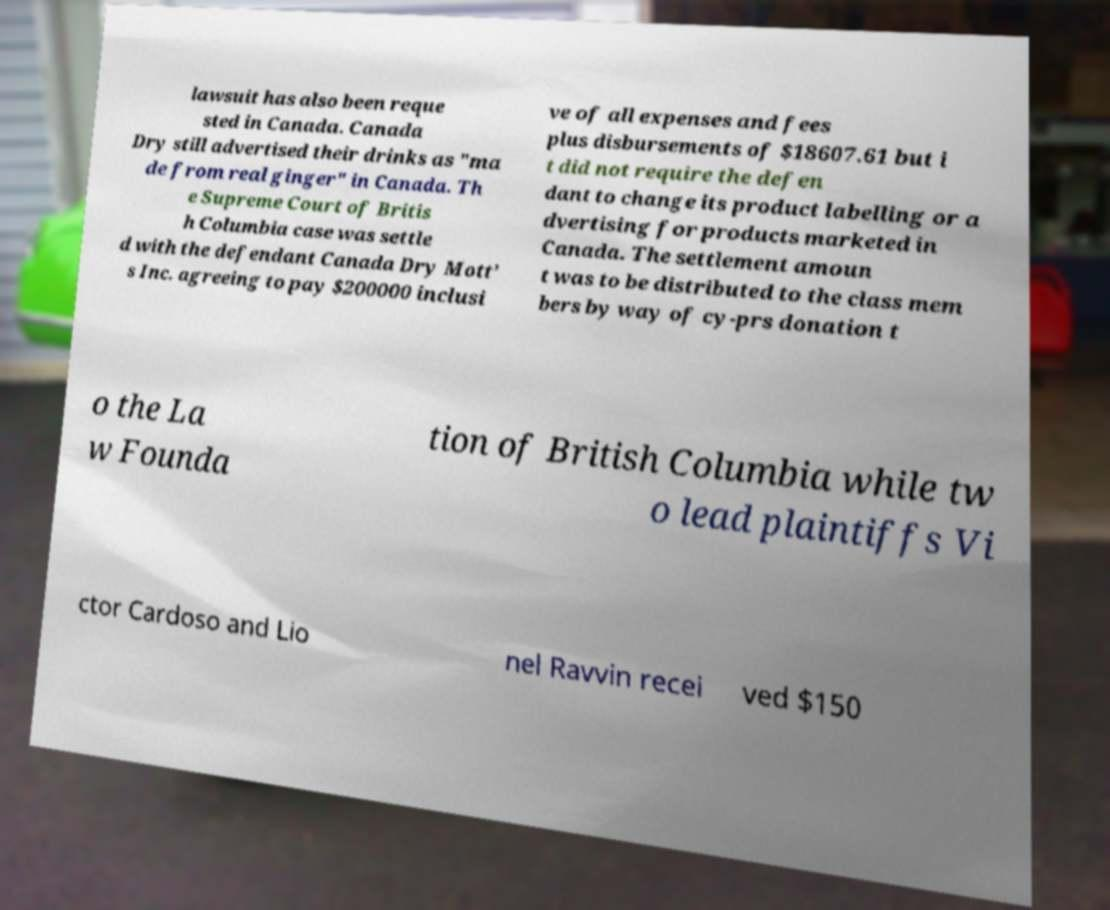Can you accurately transcribe the text from the provided image for me? lawsuit has also been reque sted in Canada. Canada Dry still advertised their drinks as "ma de from real ginger" in Canada. Th e Supreme Court of Britis h Columbia case was settle d with the defendant Canada Dry Mott’ s Inc. agreeing to pay $200000 inclusi ve of all expenses and fees plus disbursements of $18607.61 but i t did not require the defen dant to change its product labelling or a dvertising for products marketed in Canada. The settlement amoun t was to be distributed to the class mem bers by way of cy-prs donation t o the La w Founda tion of British Columbia while tw o lead plaintiffs Vi ctor Cardoso and Lio nel Ravvin recei ved $150 